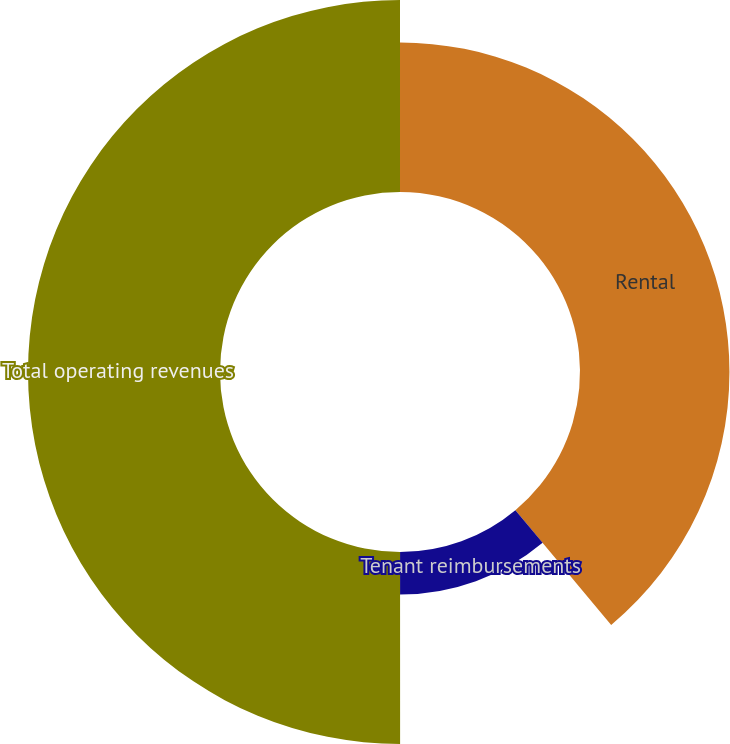Convert chart to OTSL. <chart><loc_0><loc_0><loc_500><loc_500><pie_chart><fcel>Rental<fcel>Tenant reimbursements<fcel>Total operating revenues<nl><fcel>38.93%<fcel>11.07%<fcel>50.01%<nl></chart> 